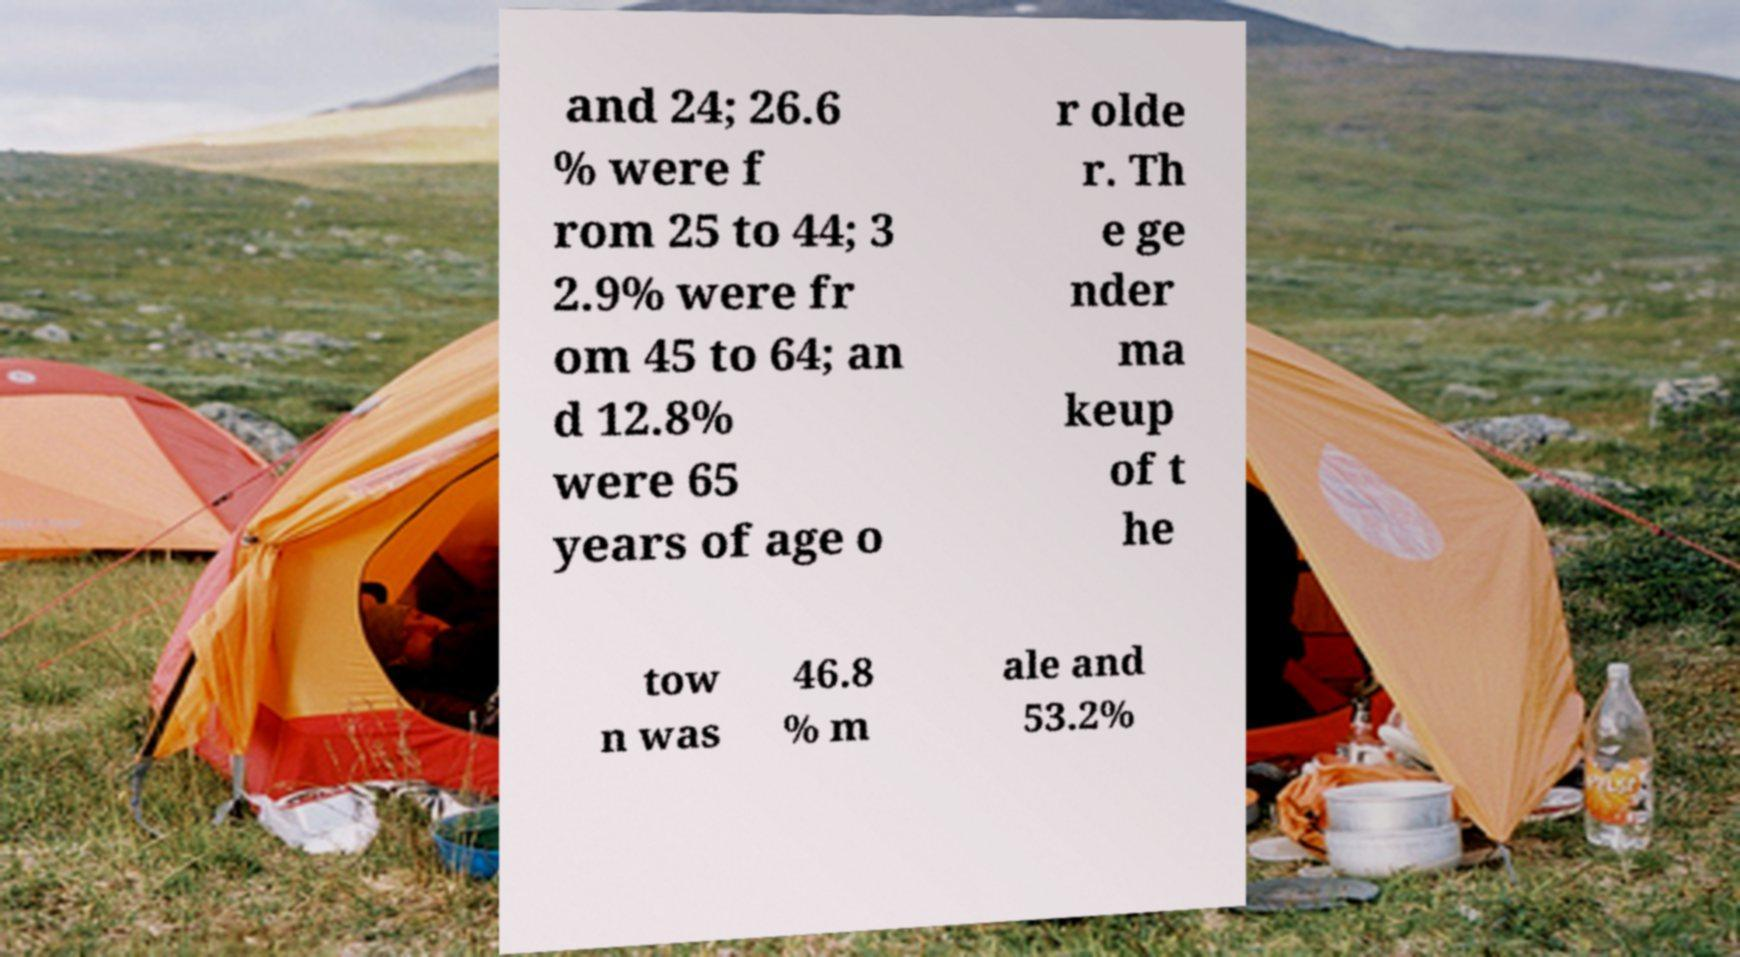Could you assist in decoding the text presented in this image and type it out clearly? and 24; 26.6 % were f rom 25 to 44; 3 2.9% were fr om 45 to 64; an d 12.8% were 65 years of age o r olde r. Th e ge nder ma keup of t he tow n was 46.8 % m ale and 53.2% 